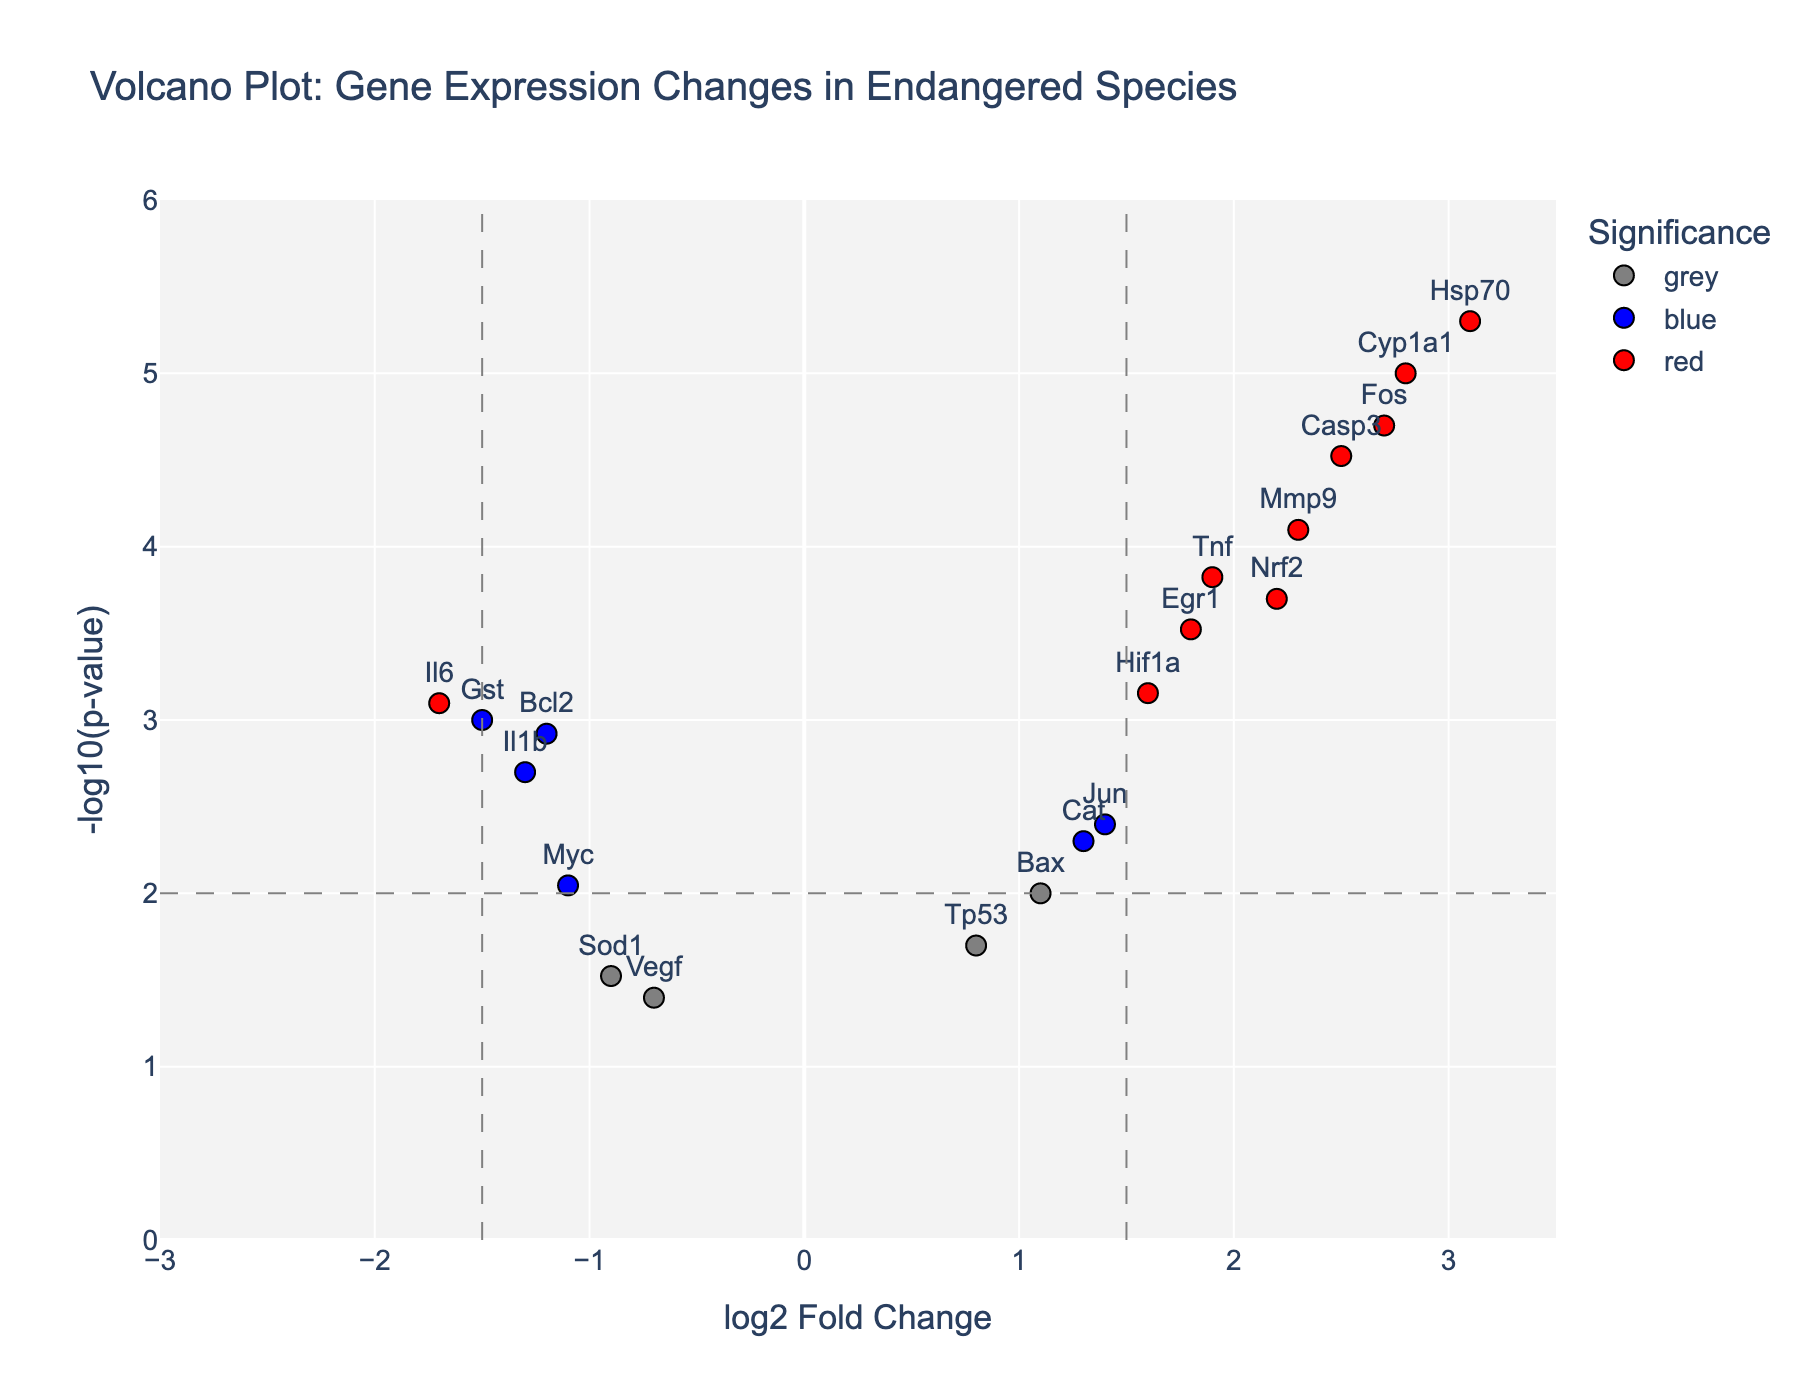How many genes are labeled in the Volcano Plot? To determine the number of labeled genes, one needs to count the visible gene labels in the plot.
Answer: 19 What is the title of the figure? The title of the figure is usually shown at the top of the plot.
Answer: Volcano Plot: Gene Expression Changes in Endangered Species What does the x-axis represent? The x-axis is labeled to indicate the variable it measures. In this plot, it is labeled as 'log2 Fold Change'.
Answer: log2 Fold Change What does the y-axis represent? The y-axis is labeled to indicate the variable it measures. In this plot, it is labeled as '-log10(p-value)'.
Answer: -log10(p-value) How many genes have a log2 Fold Change greater than 1.5? Identify the genes with log2 Fold Change values greater than 1.5 by looking at their positions on the x-axis.
Answer: 7 Which gene has the highest fold change and what is its log2 Fold Change value? Locate the gene at the extreme right of the x-axis to find the gene with the highest fold change. In this case, it's Hsp70 with a log2 Fold Change value of 3.1.
Answer: Hsp70, 3.1 How many genes are significant (p-value < 0.01) but have a log2 Fold Change less than or equal to 1.5? Look for genes with p-values less than 0.01 (high on the y-axis) and a log2 Fold Change between -1.5 and 1.5 on the x-axis.
Answer: 4 Which genes are colored red, and why? Red-colored genes represent those with absolute log2 Fold Change values greater than 1.5 and p-values less than 0.01.
Answer: Casp3, Tnf, Hsp70, Cyp1a1, Nrf2, Mmp9, Fos Which gene has the lowest p-value and what is its value? Identify the gene highest on the y-axis because this corresponds to the lowest p-value. In this plot, it's Hsp70. The p-value can be found by converting back from the -log10 scale.
Answer: Hsp70, 0.000005 What is the significance of the grey dashed lines in the figure? The grey dashed lines represent thresholds: x = ±1.5 for log2 Fold Change and y = -log10(p-value threshold of 0.01). They help in identifying significant changes in gene expression.
Answer: Shows thresholds for significance 